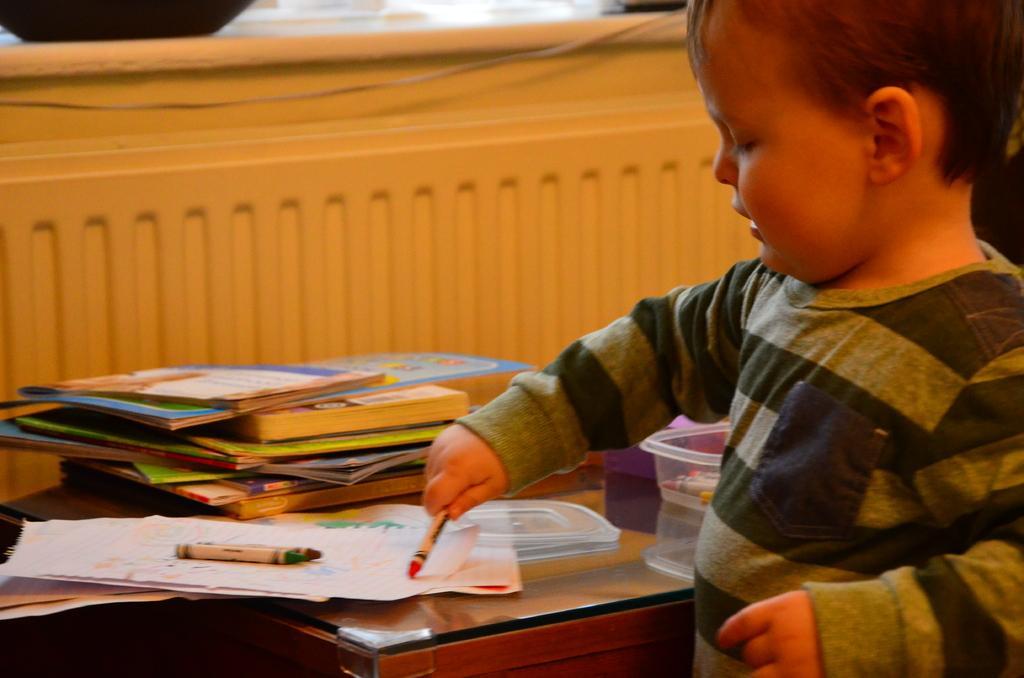Can you describe this image briefly? In this picture we can see boy playing with crayons and beside to him there is table and on table we can see books, box and here it is wall. 